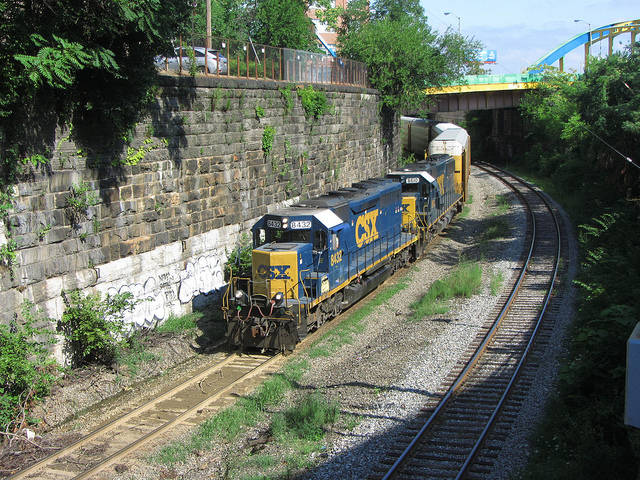Please transcribe the text information in this image. CSX CSX X 